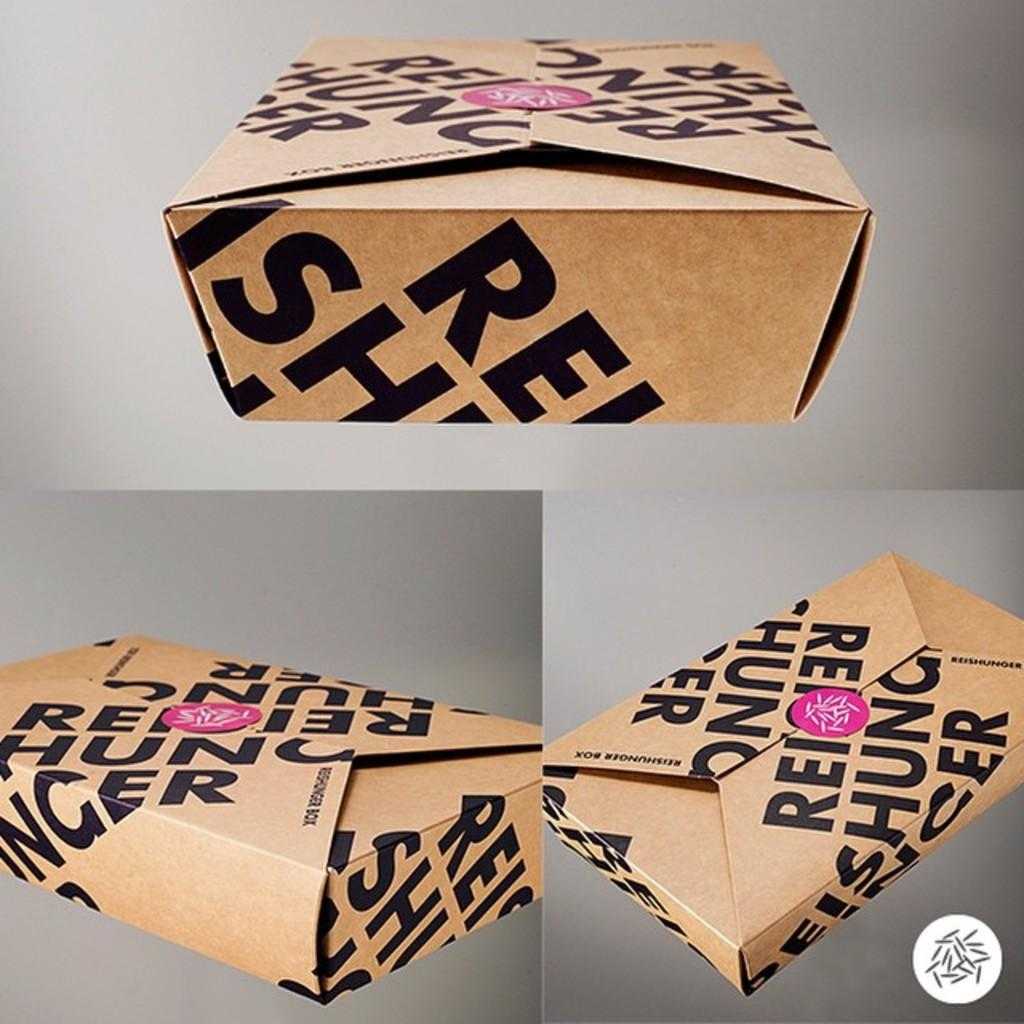<image>
Write a terse but informative summary of the picture. The three brown cardboard boxes pictured are from Resihunger 